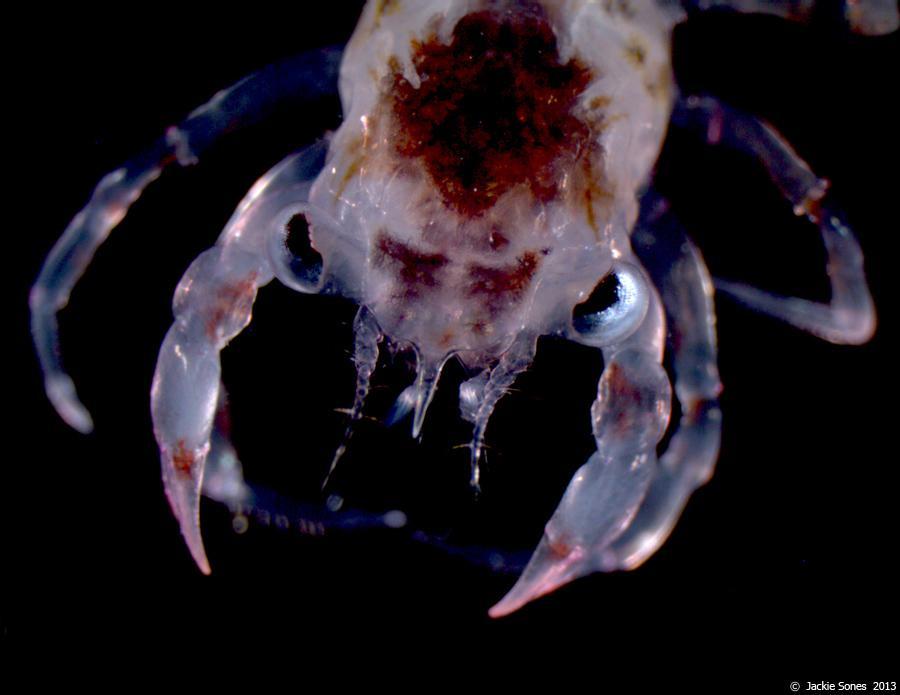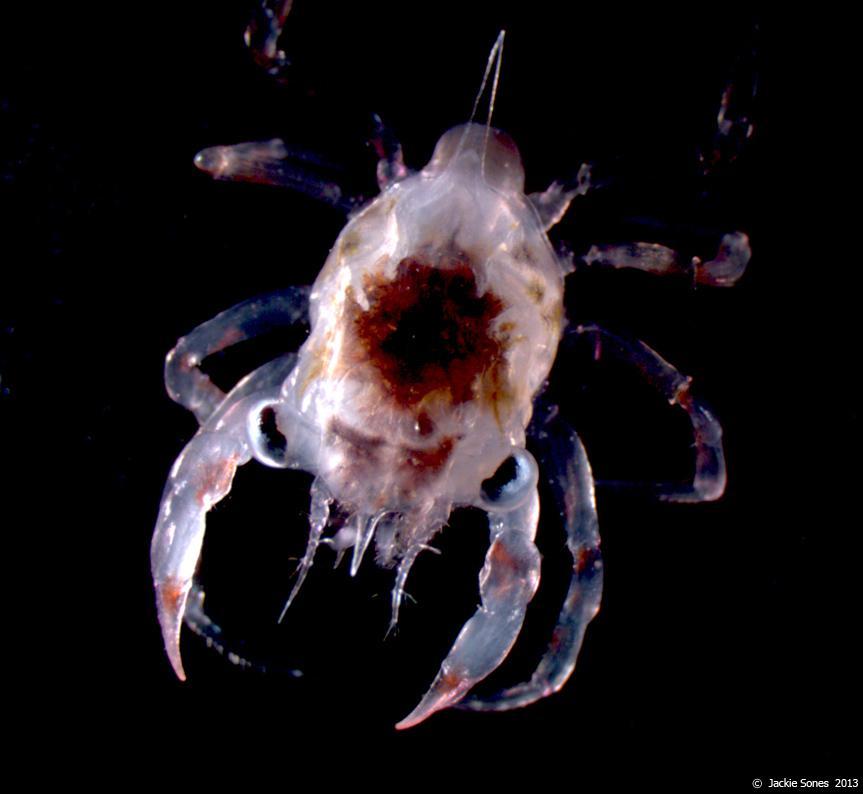The first image is the image on the left, the second image is the image on the right. Analyze the images presented: Is the assertion "Each image contains one many-legged creature, but the creatures depicted on the left and right do not have the same body shape and are not facing in the same direction." valid? Answer yes or no. No. The first image is the image on the left, the second image is the image on the right. Evaluate the accuracy of this statement regarding the images: "Two pairs of pincers are visible.". Is it true? Answer yes or no. Yes. 